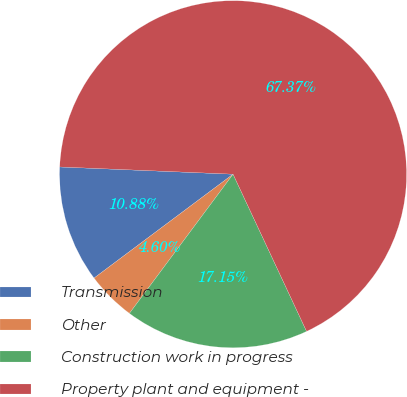Convert chart. <chart><loc_0><loc_0><loc_500><loc_500><pie_chart><fcel>Transmission<fcel>Other<fcel>Construction work in progress<fcel>Property plant and equipment -<nl><fcel>10.88%<fcel>4.6%<fcel>17.15%<fcel>67.37%<nl></chart> 